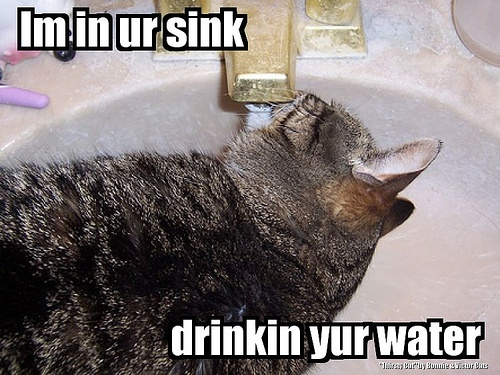Describe the objects in this image and their specific colors. I can see cat in lavender, black, gray, and darkgray tones and sink in lavender, lightgray, darkgray, and black tones in this image. 